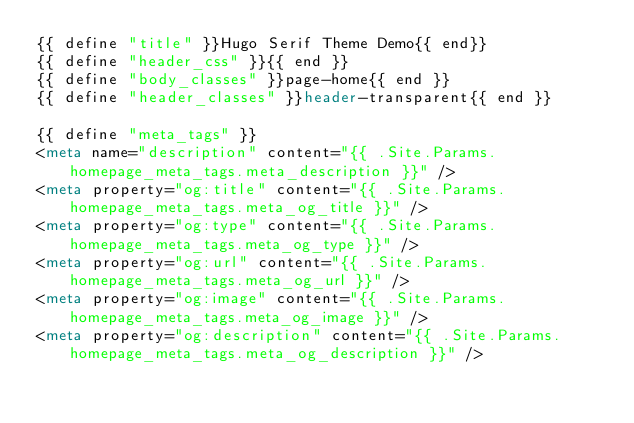<code> <loc_0><loc_0><loc_500><loc_500><_HTML_>{{ define "title" }}Hugo Serif Theme Demo{{ end}}
{{ define "header_css" }}{{ end }}
{{ define "body_classes" }}page-home{{ end }}
{{ define "header_classes" }}header-transparent{{ end }}

{{ define "meta_tags" }}
<meta name="description" content="{{ .Site.Params.homepage_meta_tags.meta_description }}" />
<meta property="og:title" content="{{ .Site.Params.homepage_meta_tags.meta_og_title }}" />
<meta property="og:type" content="{{ .Site.Params.homepage_meta_tags.meta_og_type }}" />
<meta property="og:url" content="{{ .Site.Params.homepage_meta_tags.meta_og_url }}" />
<meta property="og:image" content="{{ .Site.Params.homepage_meta_tags.meta_og_image }}" />
<meta property="og:description" content="{{ .Site.Params.homepage_meta_tags.meta_og_description }}" /></code> 